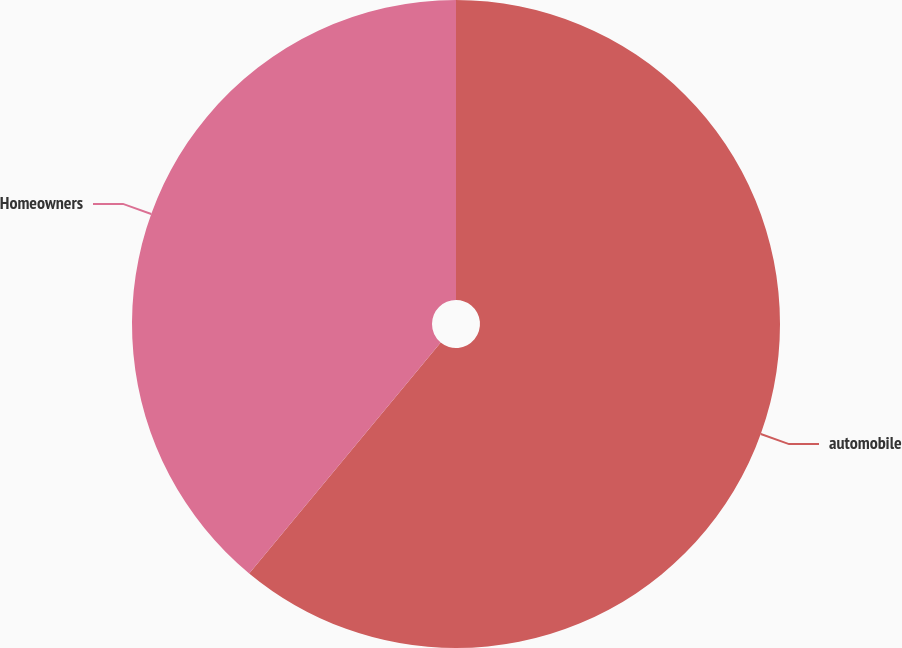Convert chart to OTSL. <chart><loc_0><loc_0><loc_500><loc_500><pie_chart><fcel>automobile<fcel>Homeowners<nl><fcel>61.02%<fcel>38.98%<nl></chart> 